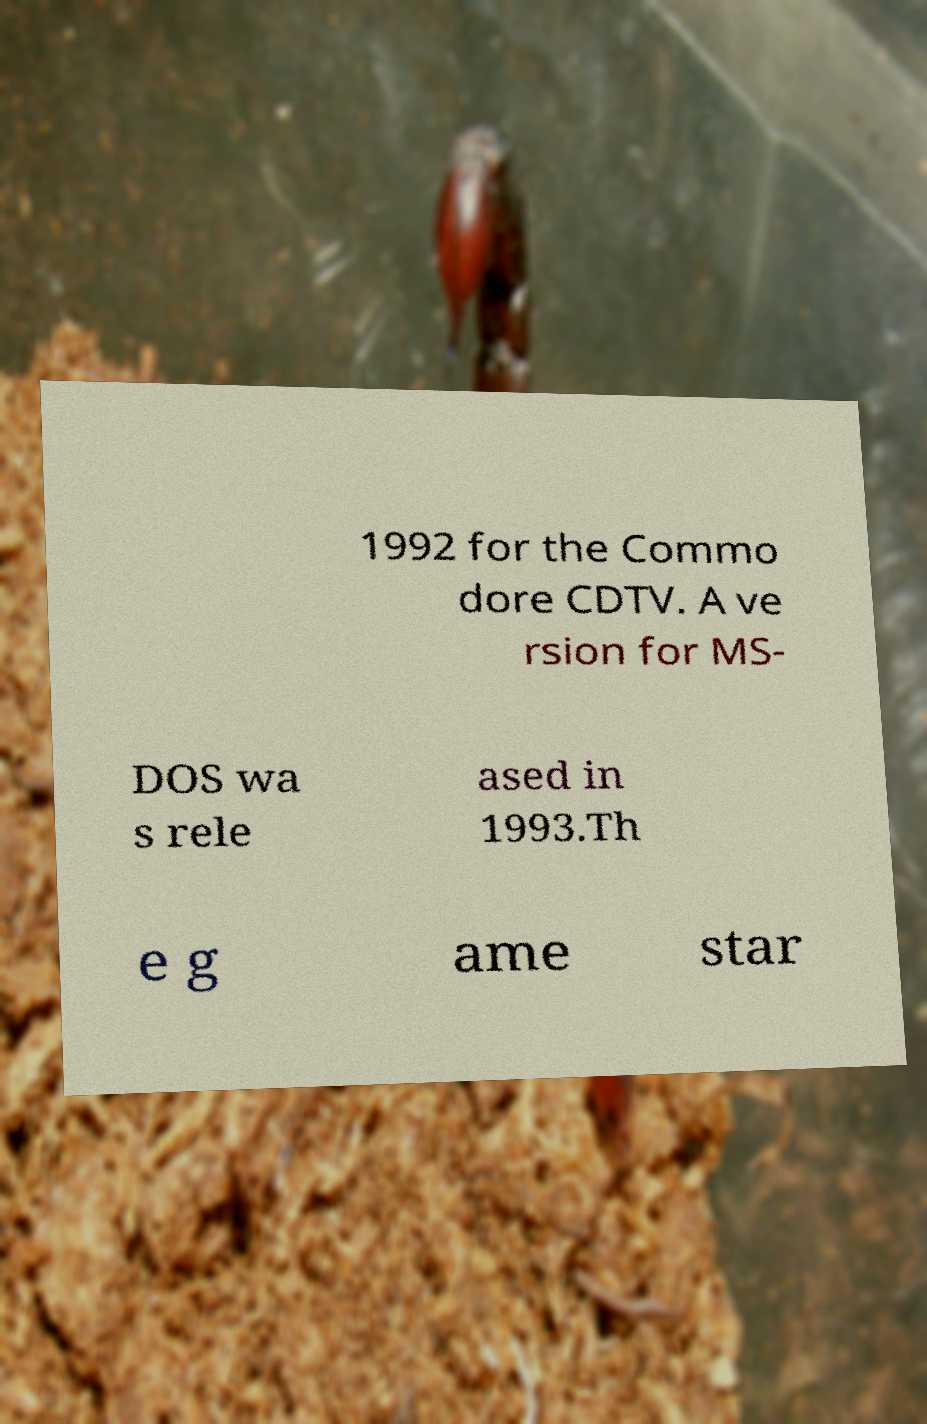What messages or text are displayed in this image? I need them in a readable, typed format. 1992 for the Commo dore CDTV. A ve rsion for MS- DOS wa s rele ased in 1993.Th e g ame star 